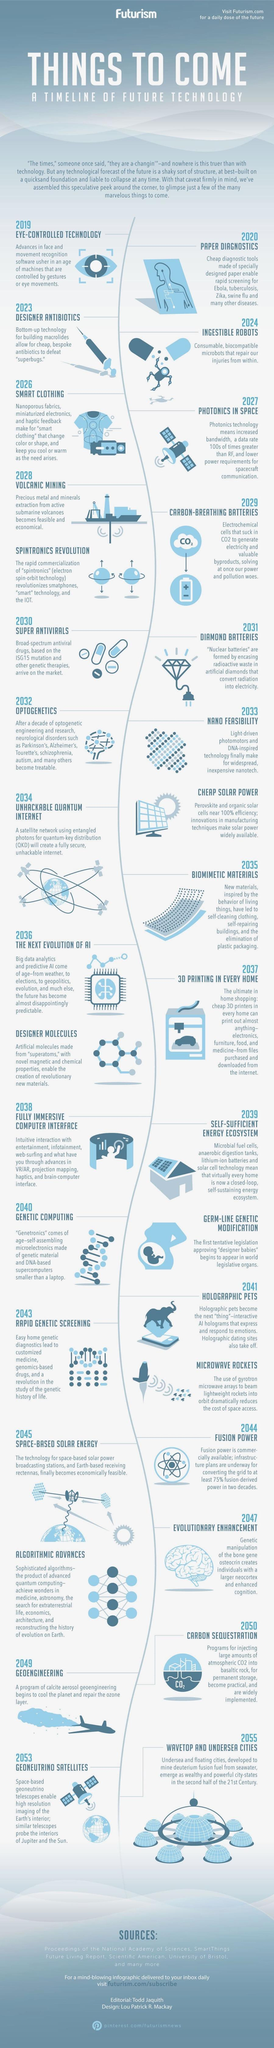What is the estimated year for the next evolution of AI in the world?
Answer the question with a short phrase. 2036 What type of microbots are expected to repair injuries within the body in 2024? INGESTIBLE ROBOTS What invention is expected to be made for the elimination of plastic packaging by 2035? BIOMIMETIC MATERIALS What technology revolution is expected to happen in the space field in 2041? MICROWAVE ROCKETS What is the estimated  year for the broad-spectrum antiviral drugs to be available in the market? 2030 What technology revolution is expected to be made in the field of genetics in 2040? GENETIC COMPUTING 